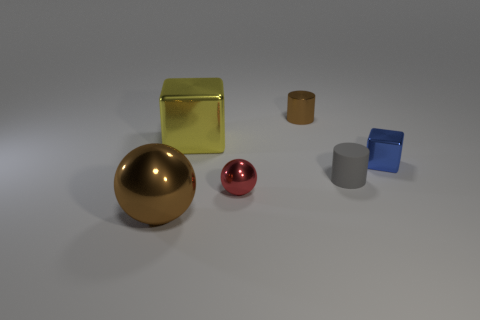Add 4 small gray cylinders. How many objects exist? 10 Subtract all spheres. How many objects are left? 4 Add 3 yellow shiny cubes. How many yellow shiny cubes are left? 4 Add 3 tiny yellow cylinders. How many tiny yellow cylinders exist? 3 Subtract 0 green cylinders. How many objects are left? 6 Subtract all big brown metal objects. Subtract all brown things. How many objects are left? 3 